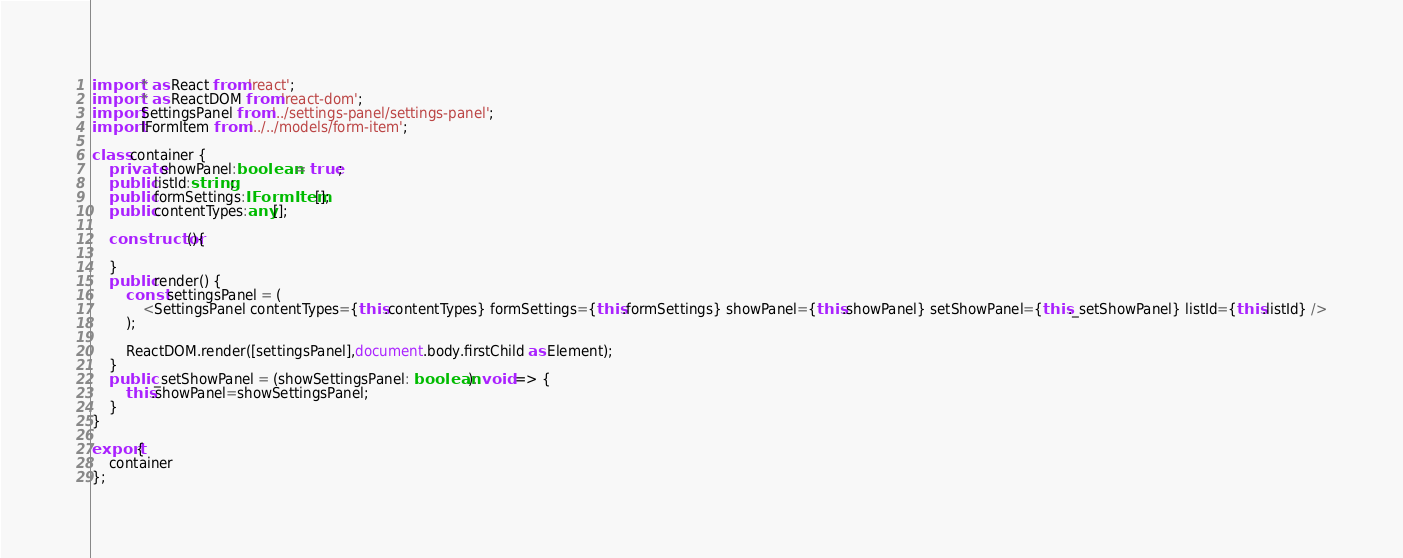<code> <loc_0><loc_0><loc_500><loc_500><_TypeScript_>import * as React from 'react';
import * as ReactDOM from 'react-dom';
import SettingsPanel from '../settings-panel/settings-panel';
import IFormItem from '../../models/form-item';

class container {
    private showPanel:boolean = true;
    public listId:string;
    public formSettings:IFormItem[];
    public contentTypes:any[];

    constructor(){
        
    }
    public render() {
        const settingsPanel = (
            <SettingsPanel contentTypes={this.contentTypes} formSettings={this.formSettings} showPanel={this.showPanel} setShowPanel={this._setShowPanel} listId={this.listId} />
        );
        
        ReactDOM.render([settingsPanel],document.body.firstChild as Element);
    }
    public _setShowPanel = (showSettingsPanel: boolean): void => {
        this.showPanel=showSettingsPanel;
    }
}

export{
    container
};</code> 